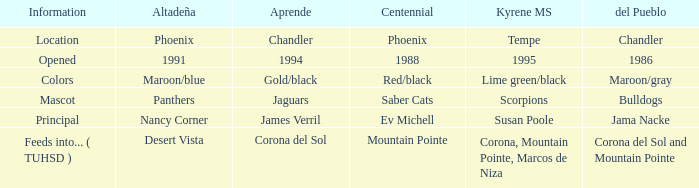WHich kind of Aprende has a Centennial of 1988? 1994.0. 